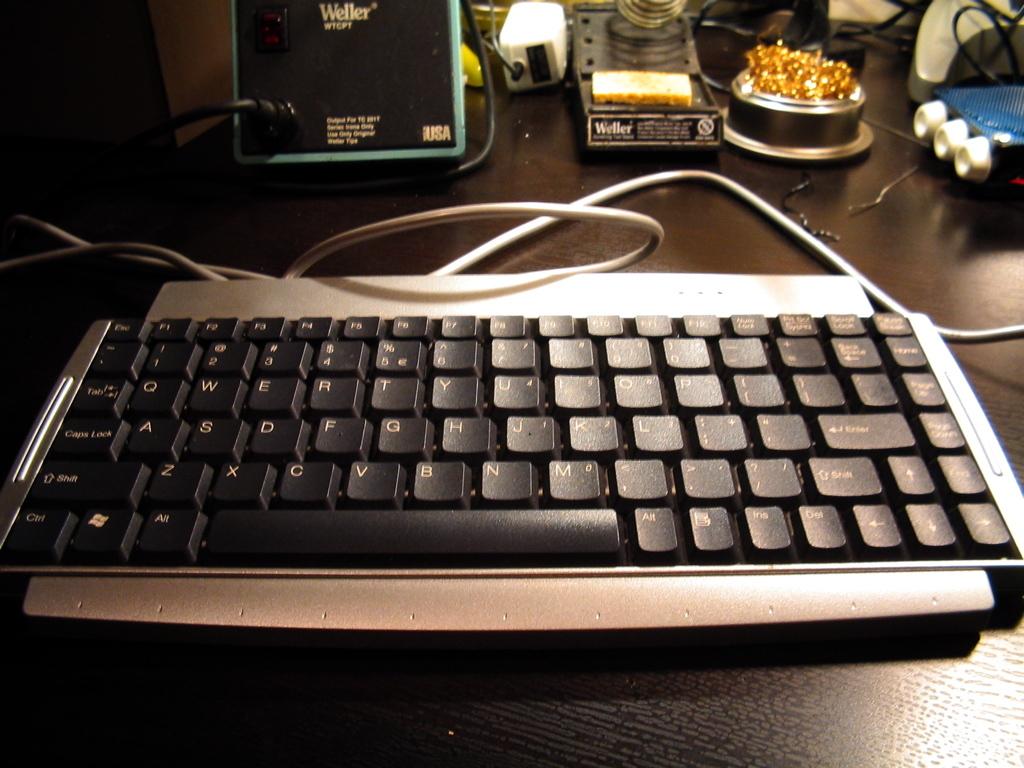What is the top left key?
Ensure brevity in your answer.  Esc. 